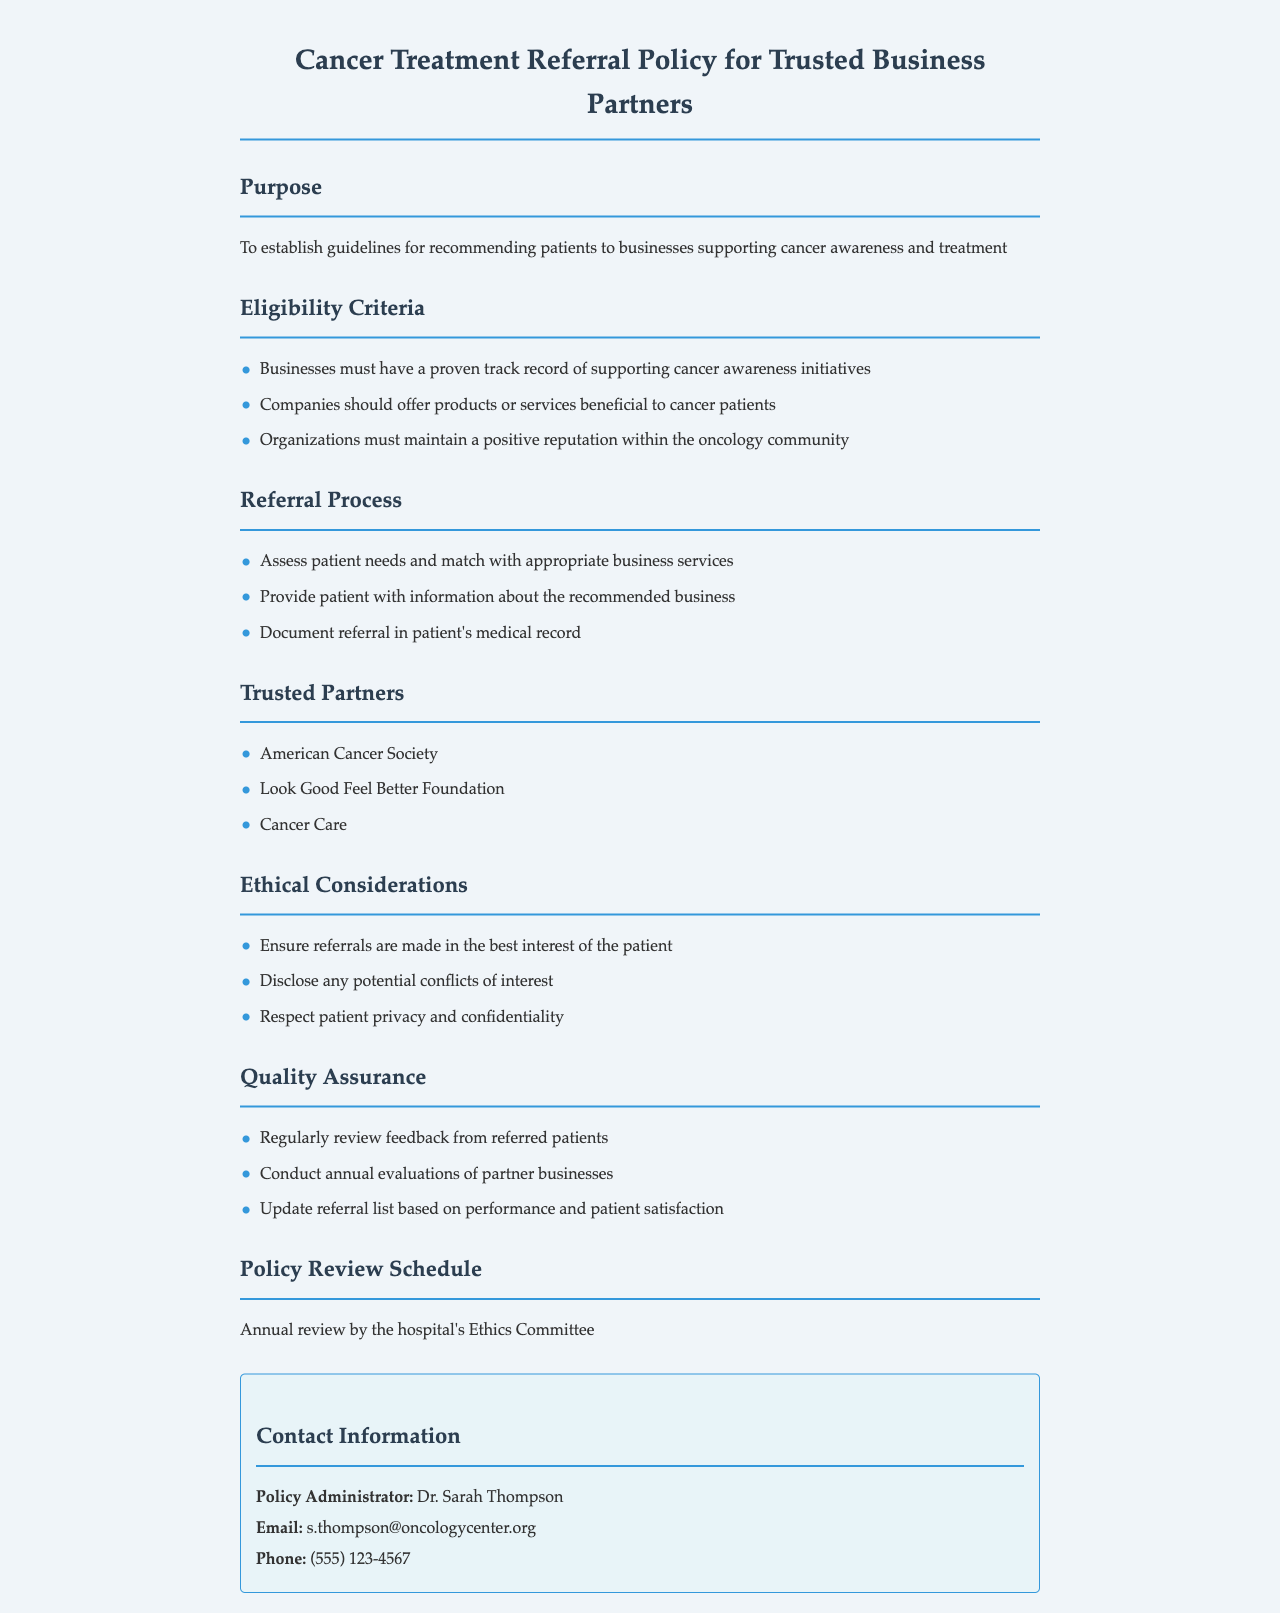What is the purpose of the policy? The purpose of the policy is to establish guidelines for recommending patients to businesses supporting cancer awareness and treatment.
Answer: To establish guidelines for recommending patients to businesses supporting cancer awareness and treatment Who is the policy administrator? The policy administrator is the individual responsible for overseeing this policy and is named in the contact information section.
Answer: Dr. Sarah Thompson What must businesses have for eligibility? Businesses must have a proven track record of supporting cancer awareness initiatives to be eligible for referral.
Answer: A proven track record of supporting cancer awareness initiatives What are the three trusted partners listed? The trusted partners are specific organizations listed under the "Trusted Partners" section.
Answer: American Cancer Society, Look Good Feel Better Foundation, Cancer Care How often is the policy reviewed? The frequency of the review is stated in the “Policy Review Schedule” section of the document.
Answer: Annually What is the first step in the referral process? The first step in the referral process involves assessing the patient’s needs.
Answer: Assess patient needs What should be documented after a referral? The specific documentation required after a referral is detailed in the referral process section.
Answer: Document referral in patient's medical record What is one ethical consideration mentioned? This refers to ensuring standards are upheld in the referral process as listed in the ethical considerations section.
Answer: Ensure referrals are made in the best interest of the patient 